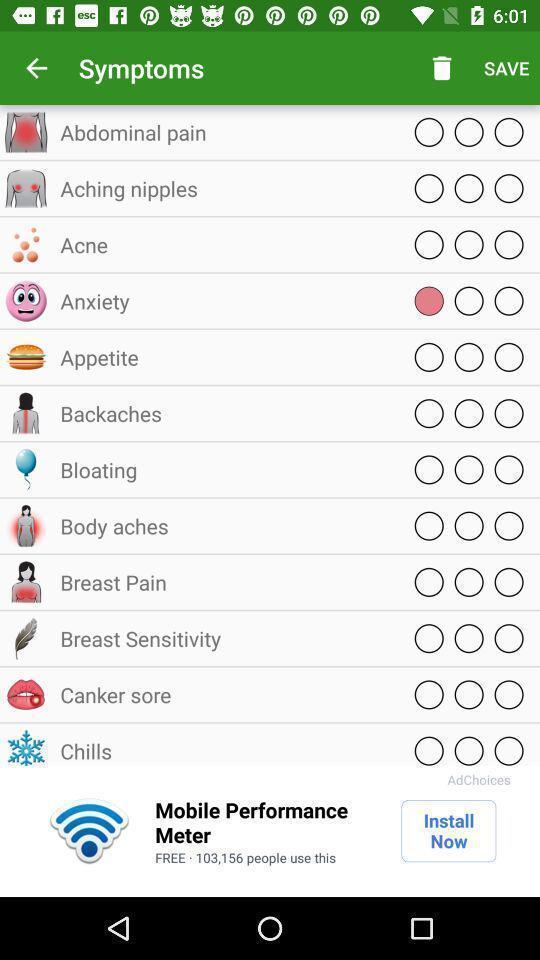Summarize the information in this screenshot. Page shows the list of various symptoms on health app. 